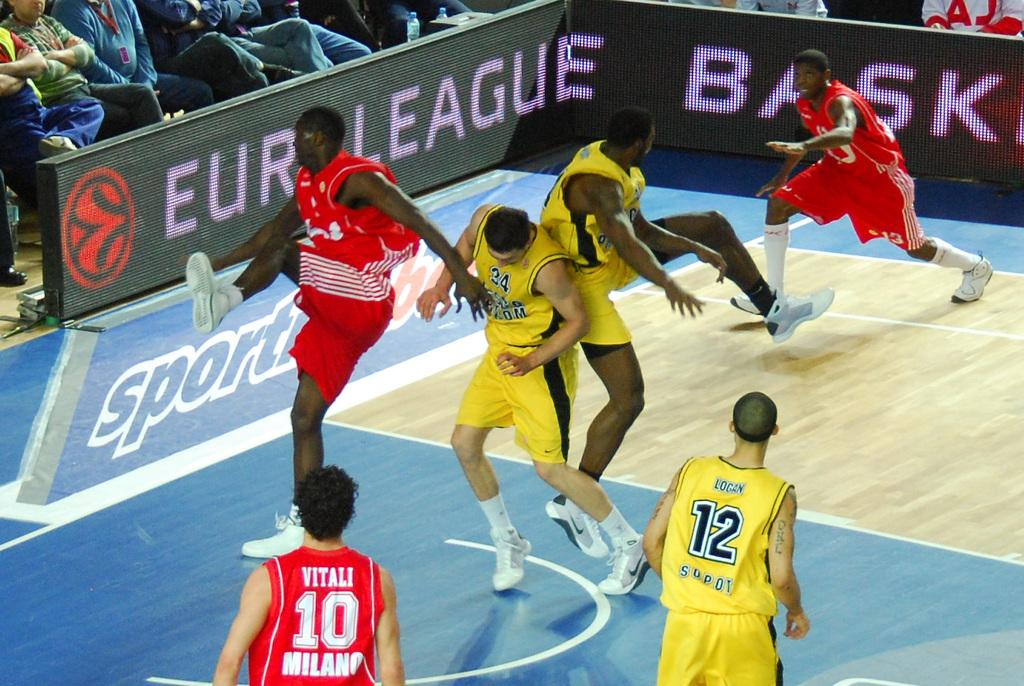<image>
Describe the image concisely. The basketball player with the last name Vitali is wearing the number 10 on his jersey 